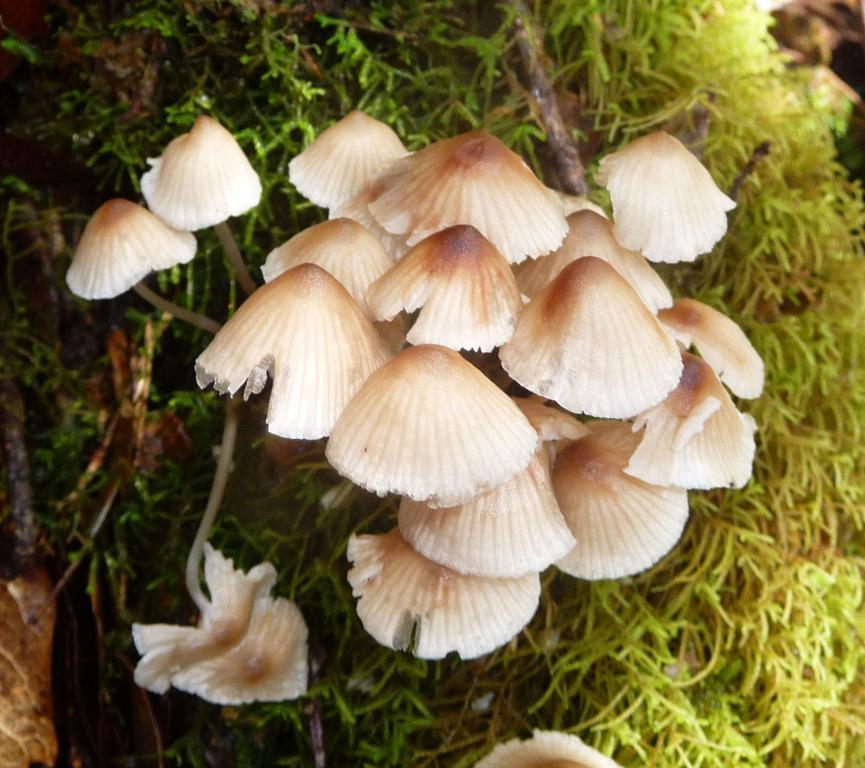What type of fungi can be seen in the image? There are mushrooms in the image. What type of vegetation is present in the image? There are trees in the image. How many trucks are parked near the mushrooms in the image? There are no trucks present in the image; it only features mushrooms and trees. What type of cooking appliance can be seen in the image? There is no cooking appliance, such as an oven, present in the image. 